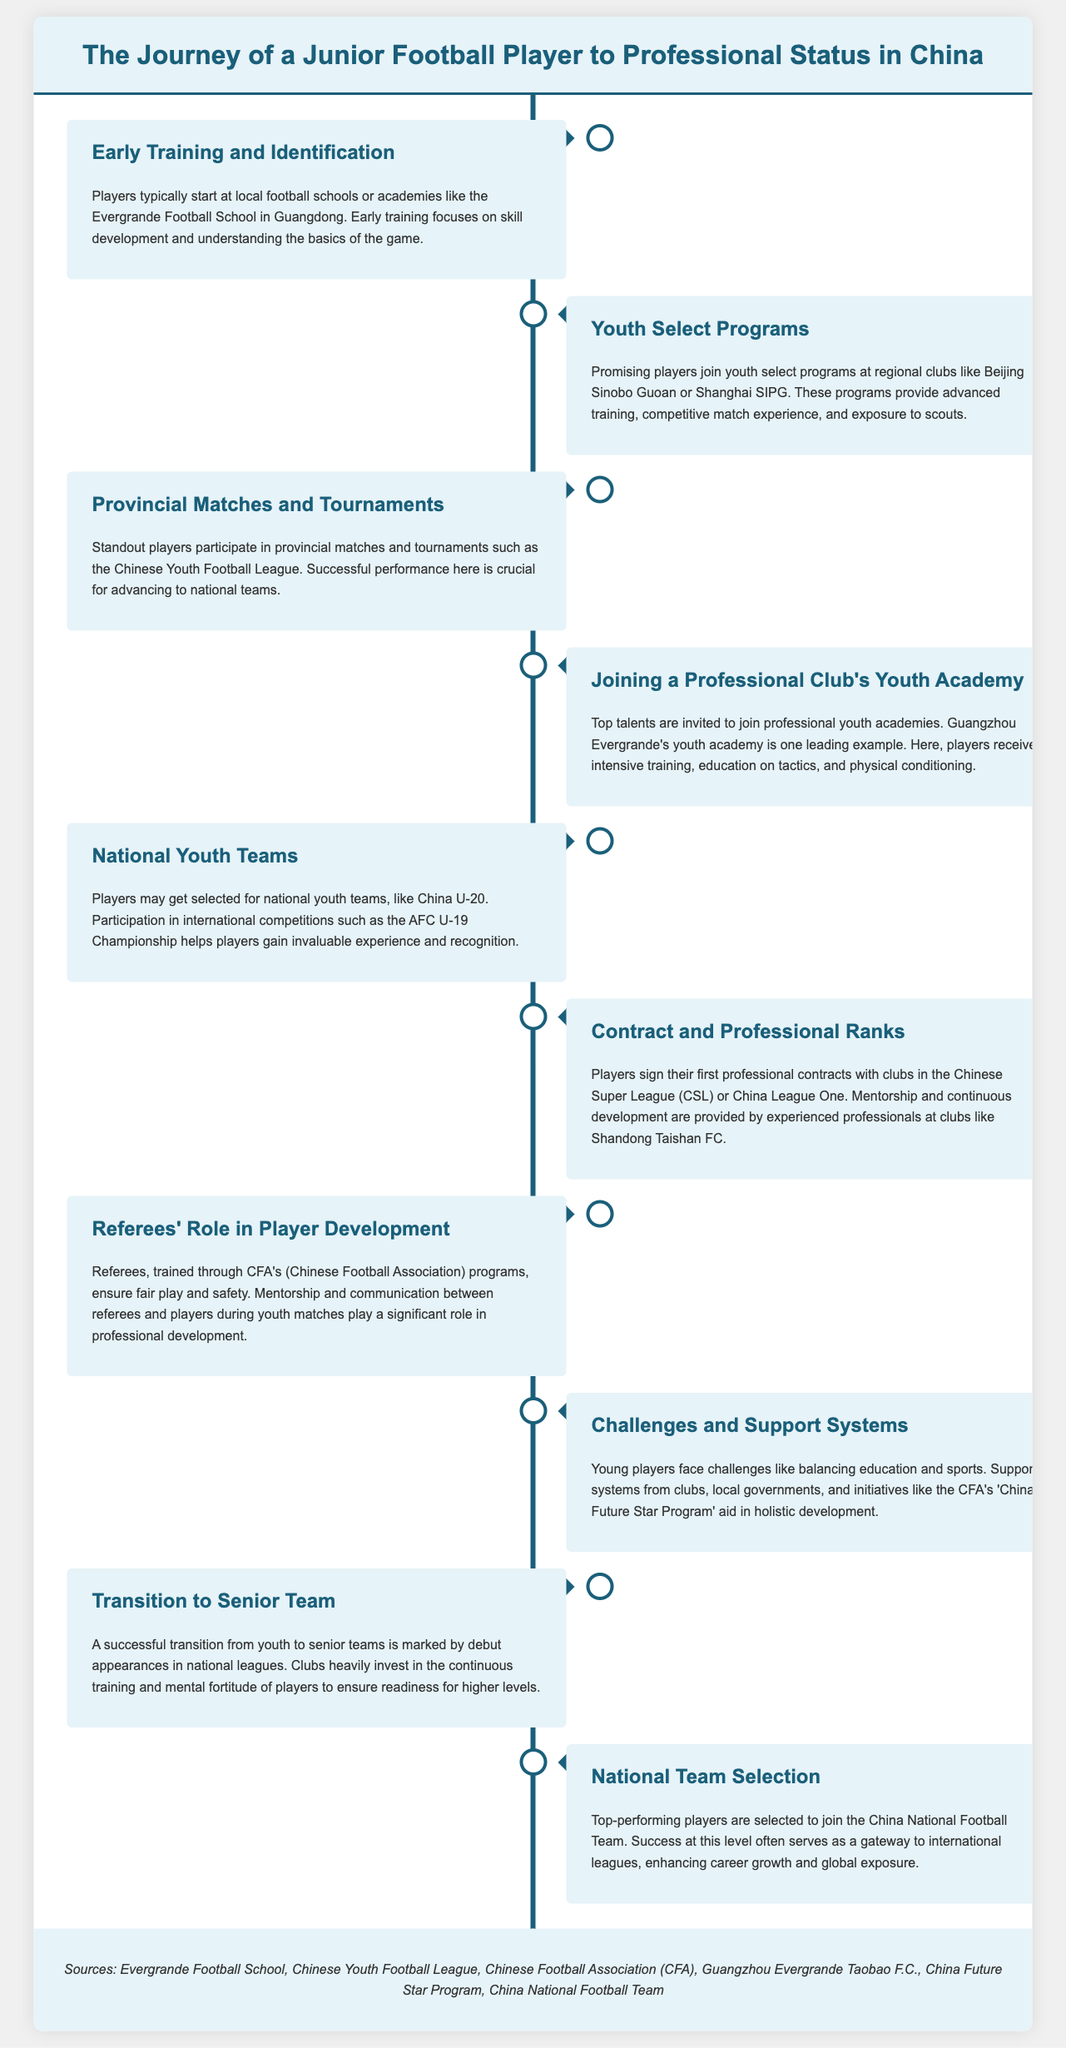What is the first step in the journey of a football player? The first step is typically starting at local football schools or academies like the Evergrande Football School in Guangdong.
Answer: Early Training and Identification Which club is mentioned in the youth select programs? The document mentions regional clubs like Beijing Sinobo Guoan or Shanghai SIPG.
Answer: Beijing Sinobo Guoan What is crucial for advancing to national teams? Successful performance in provincial matches and tournaments is crucial for advancing to national teams.
Answer: Successful performance What academy is highlighted as a leading example for youth training? The Guangzhou Evergrande's youth academy is highlighted as a leading example.
Answer: Guangzhou Evergrande In which competition do players gain invaluable experience and recognition? Players participate in international competitions such as the AFC U-19 Championship for invaluable experience.
Answer: AFC U-19 Championship What role do referees play in player development? Referees ensure fair play and safety, and their mentorship and communication are significant in player development.
Answer: Ensure fair play What is a challenge young players face according to the document? Young players face challenges like balancing education and sports.
Answer: Balancing education and sports What marks the transition from youth to senior teams? A successful transition is marked by debut appearances in national leagues.
Answer: Debut appearances Which national team may players be selected to join? Players may be selected to join the China National Football Team.
Answer: China National Football Team 